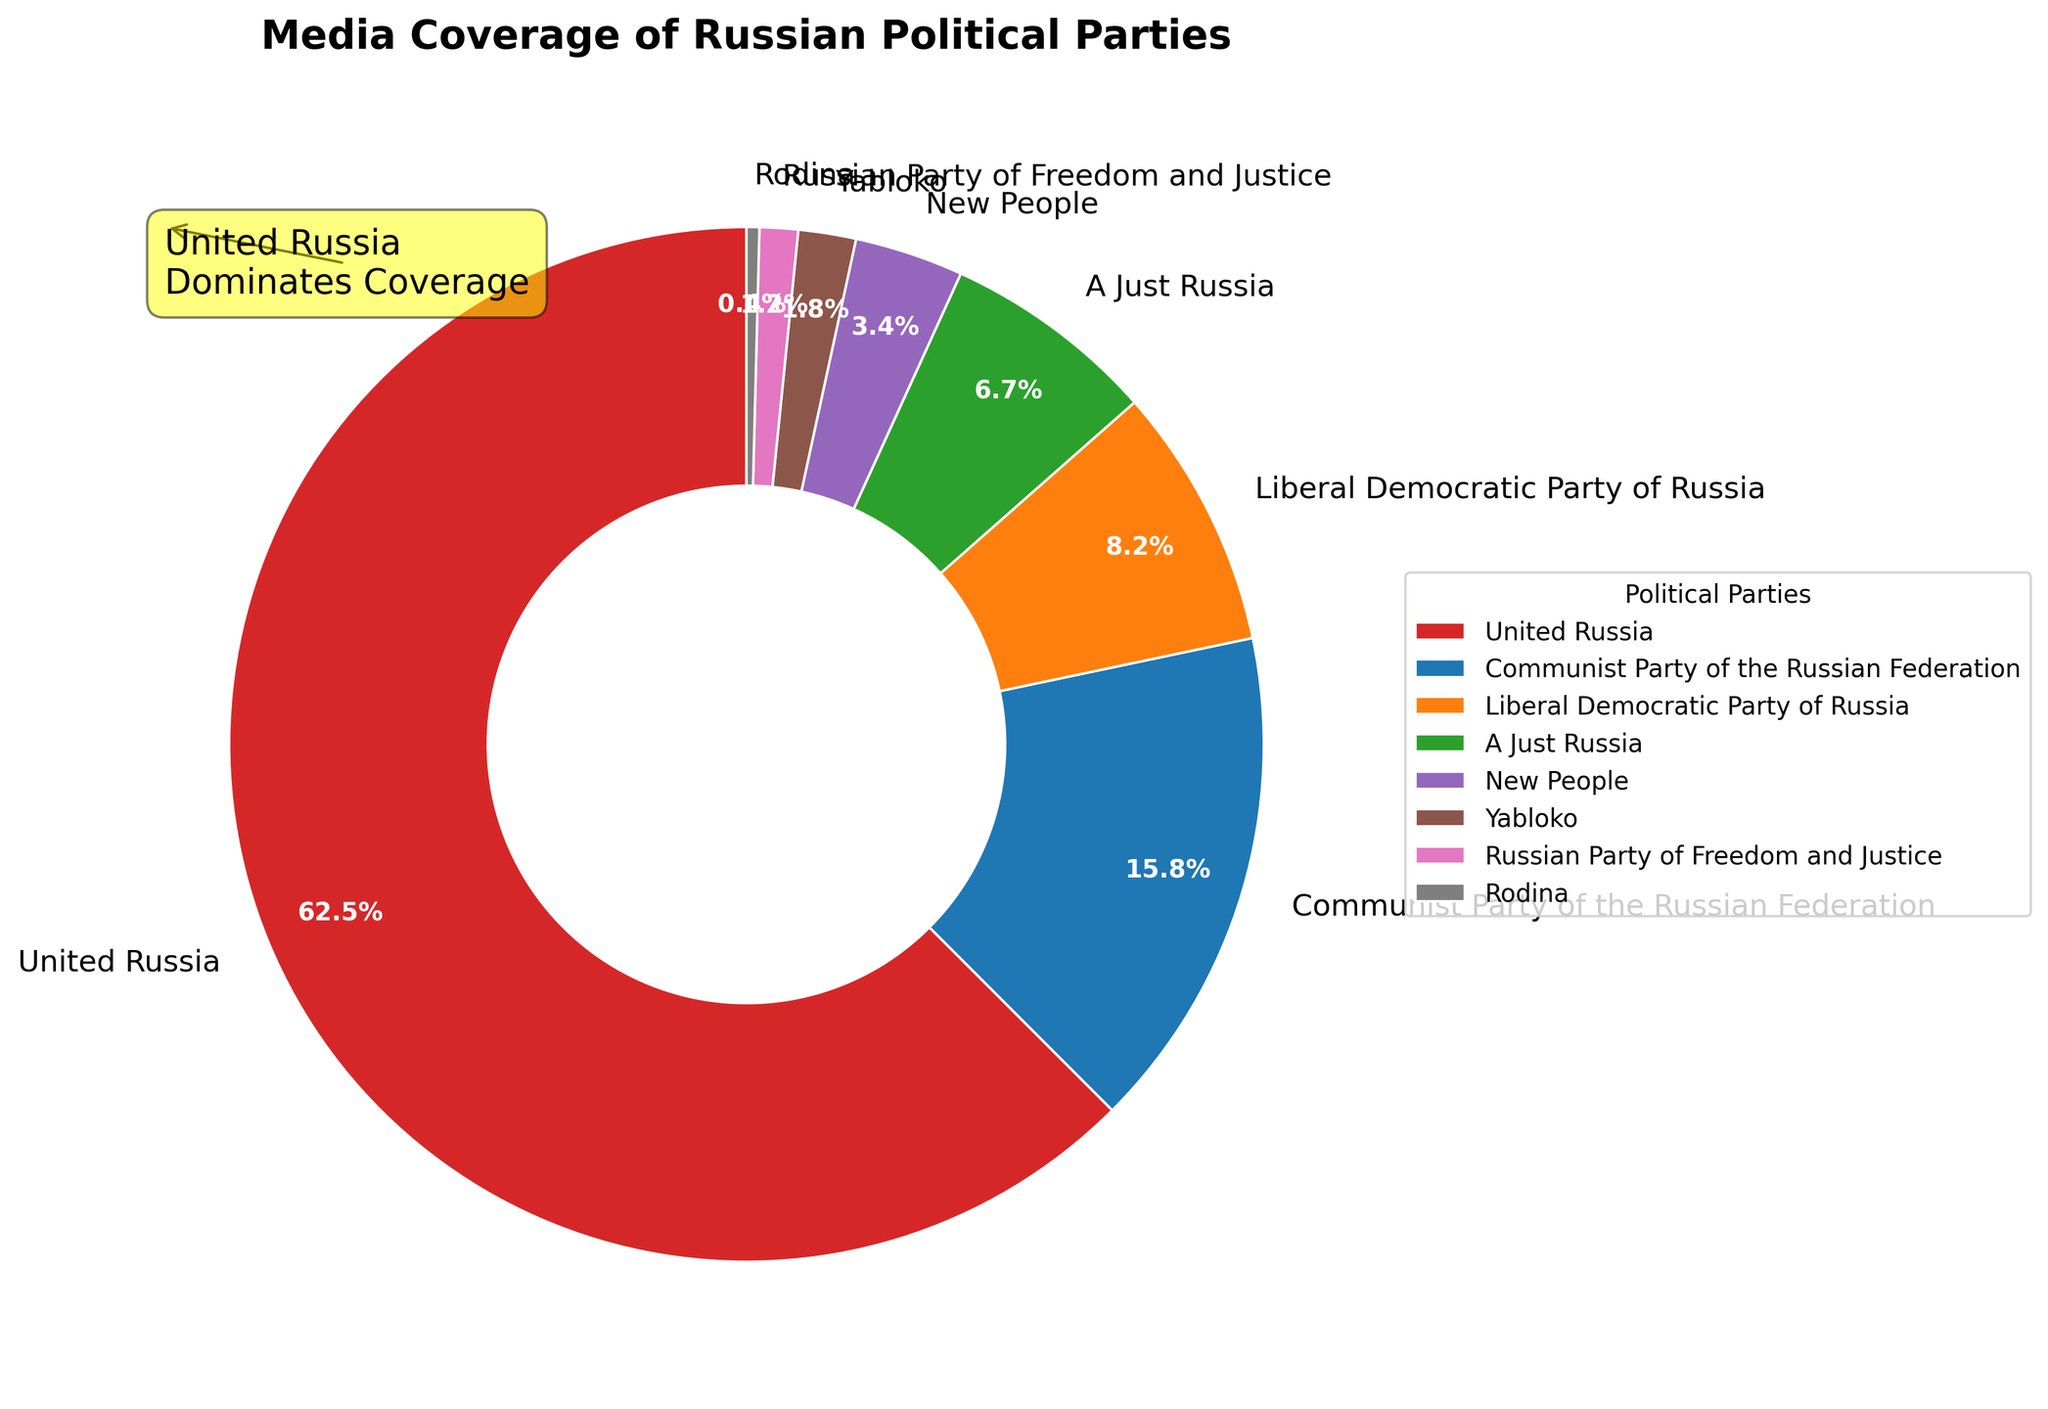What percentage of media coverage does United Russia receive? United Russia receives 62.5% of the media coverage. This can be directly observed from the pie chart where United Russia's segment is labeled with 62.5%.
Answer: 62.5% Which party has the second highest media coverage after United Russia? The second highest media coverage is received by the Communist Party of the Russian Federation. This is evident from the pie chart where the Communist Party of the Russian Federation is labeled with 15.8%.
Answer: Communist Party of the Russian Federation How much more media coverage does United Russia receive compared to all other parties combined? United Russia receives 62.5%. The combined percentage of all other parties is 37.5% (100% - 62.5%). Therefore, United Russia receives 62.5% - 37.5% = 25% more coverage.
Answer: 25% What is the combined percentage of media coverage of the Communist Party of the Russian Federation and the Liberal Democratic Party of Russia? The media coverage percentages for the Communist Party of the Russian Federation and the Liberal Democratic Party of Russia are 15.8% and 8.2%, respectively. Combining these gives 15.8% + 8.2% = 24%.
Answer: 24% Which party has the least media coverage, and what percentage do they receive? The party with the least media coverage is Rodina, which receives 0.4%. This is the smallest segment shown in the pie chart.
Answer: Rodina, 0.4% How does the percentage of media coverage for A Just Russia compare to New People? A Just Russia has 6.7% of media coverage while New People receives 3.4%. Thus, A Just Russia has 6.7% - 3.4% = 3.3% more media coverage than New People.
Answer: 3.3% more Rank the parties from highest to lowest in terms of media coverage. The percentages of media coverage are given in the pie chart. Ranking them from highest to lowest: 1) United Russia: 62.5%, 2) Communist Party of the Russian Federation: 15.8%, 3) Liberal Democratic Party of Russia: 8.2%, 4) A Just Russia: 6.7%, 5) New People: 3.4%, 6) Yabloko: 1.8%, 7) Russian Party of Freedom and Justice: 1.2%, 8) Rodina: 0.4%.
Answer: United Russia, Communist Party of the Russian Federation, Liberal Democratic Party of Russia, A Just Russia, New People, Yabloko, Russian Party of Freedom and Justice, Rodina What is the combined media coverage percentage of the smallest three parties? The three smallest parties are Yabloko (1.8%), Russian Party of Freedom and Justice (1.2%), and Rodina (0.4%). Their combined percentage is 1.8% + 1.2% + 0.4% = 3.4%.
Answer: 3.4% Which parties receive less than 5% media coverage, and what are their percentages? The parties receiving less than 5% media coverage are New People (3.4%), Yabloko (1.8%), Russian Party of Freedom and Justice (1.2%), and Rodina (0.4%) as indicated by the pie chart.
Answer: New People: 3.4%, Yabloko: 1.8%, Russian Party of Freedom and Justice: 1.2%, Rodina: 0.4% What observations can be made about the dominance of United Russia in media coverage? United Russia receives 62.5% of the media coverage, which is significantly higher than any other party. The Communist Party of the Russian Federation, with the second highest coverage, only has 15.8%. This suggests that United Russia dominates the media landscape by a large margin, which ensures it has significant public visibility.
Answer: United Russia dominates media coverage How does the visual attribute (color) help differentiate between the parties in the pie chart? Different colors are used to represent each party to help visually differentiate between them. For example, United Russia has its own distinct color, which is different from the colors of other parties such as the Communist Party of the Russian Federation and the Liberal Democratic Party of Russia. This use of colors makes it easier to identify and compare the segments in the pie chart.
Answer: Color differentiation makes identification easy 